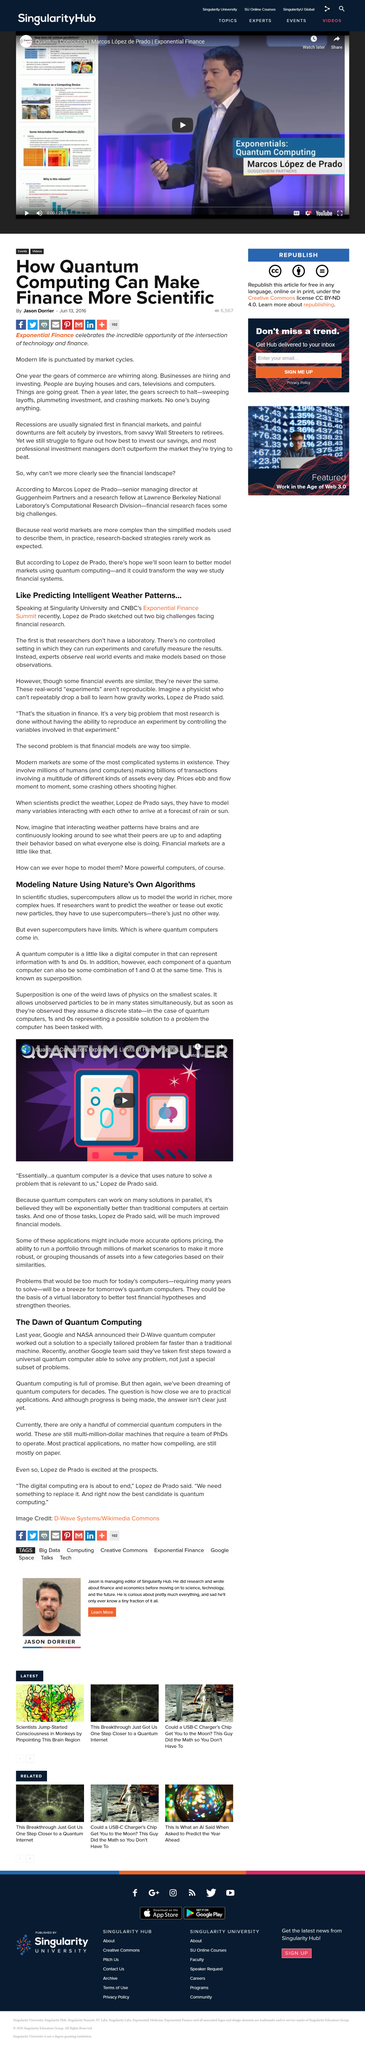Point out several critical features in this image. Google and NASA collaborated to create the D-Wave quantum computer. For many decades, we have dreamed of the type of computer that Google and NASA's D-Wave is. Quantum computers have the ability to represent information using both 1s and 0s simultaneously, making them capable of processing multiple pieces of information at once. Financial researchers do not have a laboratory. Quantum computers have surpassed traditional supercomputers in terms of processing power and capabilities. 